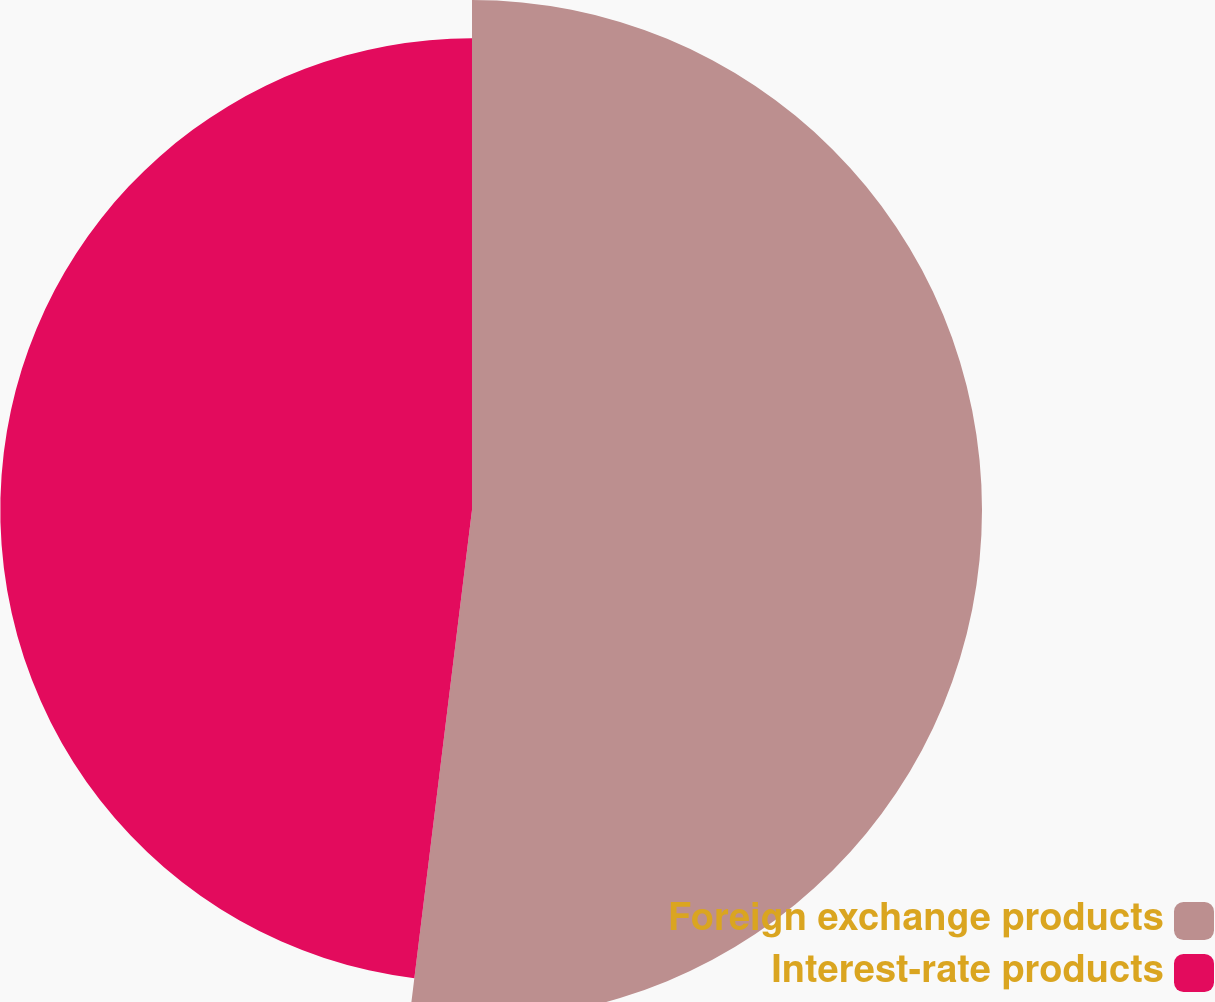Convert chart to OTSL. <chart><loc_0><loc_0><loc_500><loc_500><pie_chart><fcel>Foreign exchange products<fcel>Interest-rate products<nl><fcel>51.95%<fcel>48.05%<nl></chart> 